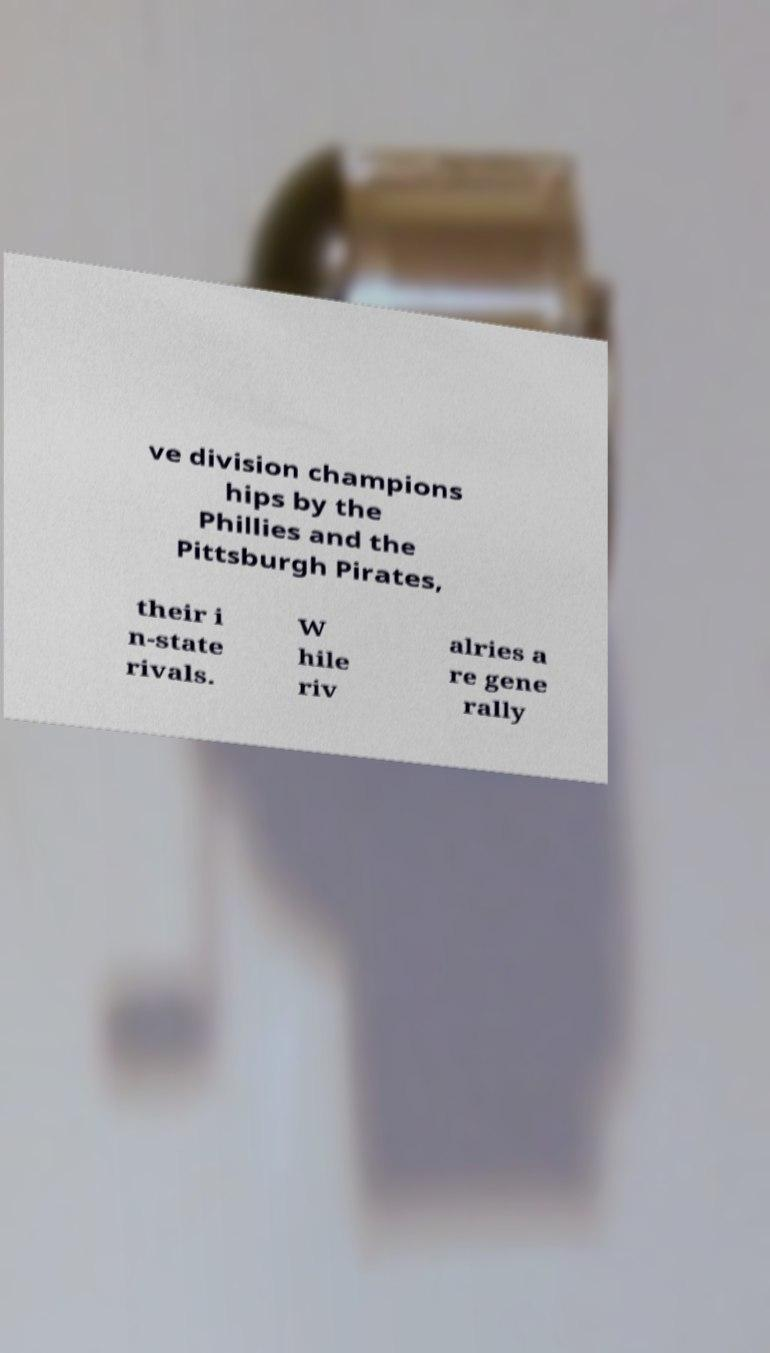What messages or text are displayed in this image? I need them in a readable, typed format. ve division champions hips by the Phillies and the Pittsburgh Pirates, their i n-state rivals. W hile riv alries a re gene rally 